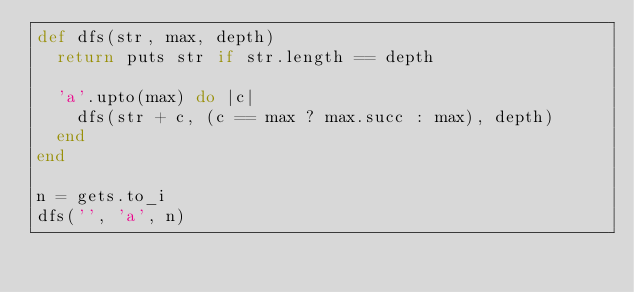<code> <loc_0><loc_0><loc_500><loc_500><_Ruby_>def dfs(str, max, depth)
  return puts str if str.length == depth

  'a'.upto(max) do |c|
    dfs(str + c, (c == max ? max.succ : max), depth)
  end
end

n = gets.to_i
dfs('', 'a', n)
</code> 